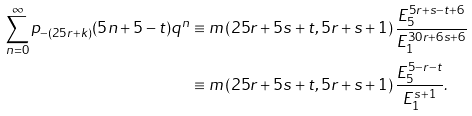Convert formula to latex. <formula><loc_0><loc_0><loc_500><loc_500>\sum _ { n = 0 } ^ { \infty } p _ { - ( 2 5 r + k ) } ( 5 n + 5 - t ) q ^ { n } & \equiv m \left ( 2 5 r + 5 s + t , 5 r + s + 1 \right ) \frac { E _ { 5 } ^ { 5 r + s - t + 6 } } { E _ { 1 } ^ { 3 0 r + 6 s + 6 } } \\ & \equiv m \left ( 2 5 r + 5 s + t , 5 r + s + 1 \right ) \frac { E _ { 5 } ^ { 5 - r - t } } { E _ { 1 } ^ { s + 1 } } .</formula> 